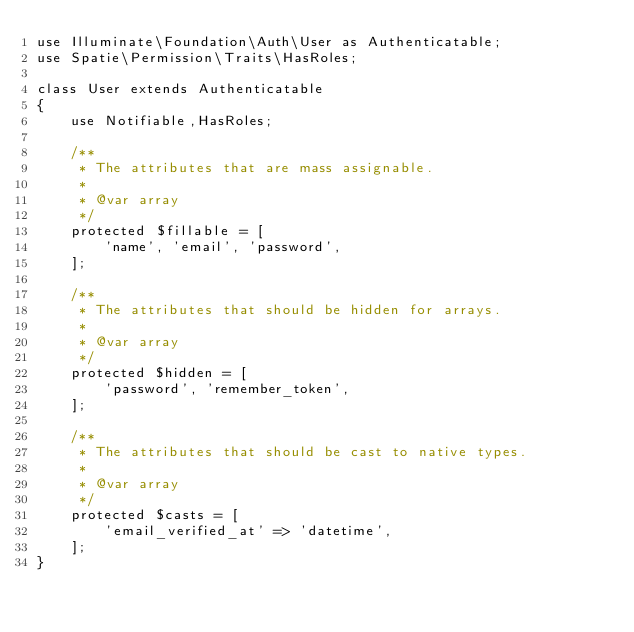Convert code to text. <code><loc_0><loc_0><loc_500><loc_500><_PHP_>use Illuminate\Foundation\Auth\User as Authenticatable;
use Spatie\Permission\Traits\HasRoles;

class User extends Authenticatable
{
    use Notifiable,HasRoles;

    /**
     * The attributes that are mass assignable.
     *
     * @var array
     */
    protected $fillable = [
        'name', 'email', 'password',
    ];

    /**
     * The attributes that should be hidden for arrays.
     *
     * @var array
     */
    protected $hidden = [
        'password', 'remember_token',
    ];

    /**
     * The attributes that should be cast to native types.
     *
     * @var array
     */
    protected $casts = [
        'email_verified_at' => 'datetime',
    ];
}
</code> 